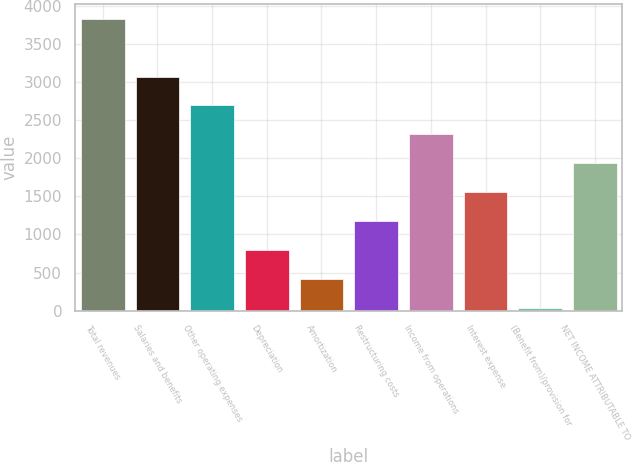<chart> <loc_0><loc_0><loc_500><loc_500><bar_chart><fcel>Total revenues<fcel>Salaries and benefits<fcel>Other operating expenses<fcel>Depreciation<fcel>Amortization<fcel>Restructuring costs<fcel>Income from operations<fcel>Interest expense<fcel>(Benefit from)/provision for<fcel>NET INCOME ATTRIBUTABLE TO<nl><fcel>3829<fcel>3069.8<fcel>2690.2<fcel>792.2<fcel>412.6<fcel>1171.8<fcel>2310.6<fcel>1551.4<fcel>33<fcel>1931<nl></chart> 